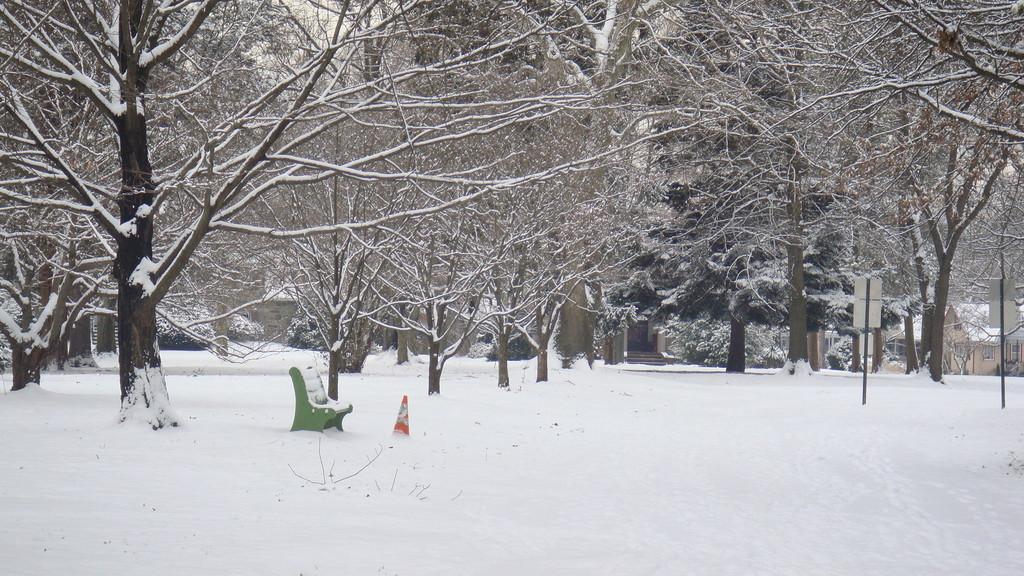Describe this image in one or two sentences. In this image I can see the snow. I can see the bench, traffic cone, poles and boards. In the background I can see many trees. 